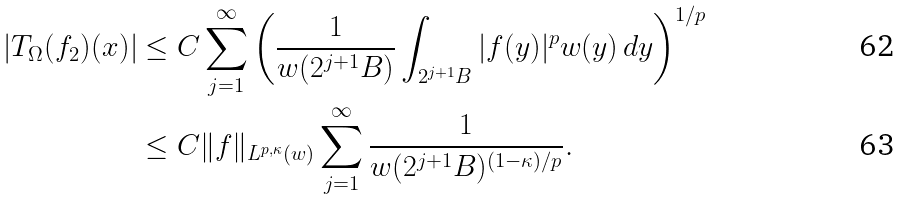<formula> <loc_0><loc_0><loc_500><loc_500>\left | T _ { \Omega } ( f _ { 2 } ) ( x ) \right | & \leq C \sum _ { j = 1 } ^ { \infty } \left ( \frac { 1 } { w ( 2 ^ { j + 1 } B ) } \int _ { 2 ^ { j + 1 } B } | f ( y ) | ^ { p } w ( y ) \, d y \right ) ^ { 1 / { p } } \\ & \leq C \| f \| _ { L ^ { p , \kappa } ( w ) } \sum _ { j = 1 } ^ { \infty } \frac { 1 } { w ( 2 ^ { j + 1 } B ) ^ { ( 1 - \kappa ) / p } } .</formula> 